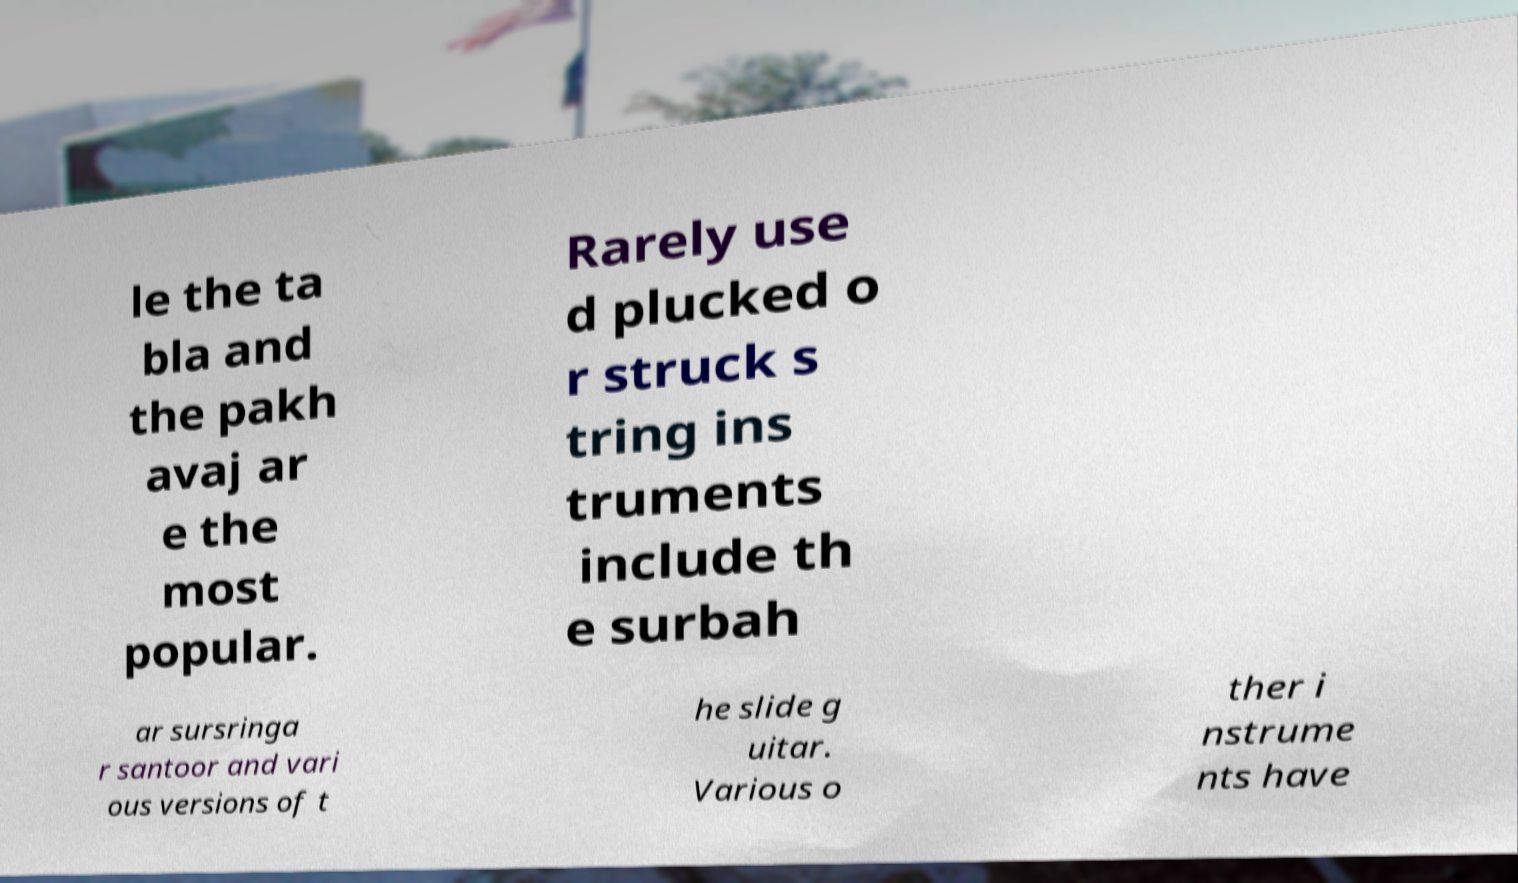What messages or text are displayed in this image? I need them in a readable, typed format. le the ta bla and the pakh avaj ar e the most popular. Rarely use d plucked o r struck s tring ins truments include th e surbah ar sursringa r santoor and vari ous versions of t he slide g uitar. Various o ther i nstrume nts have 